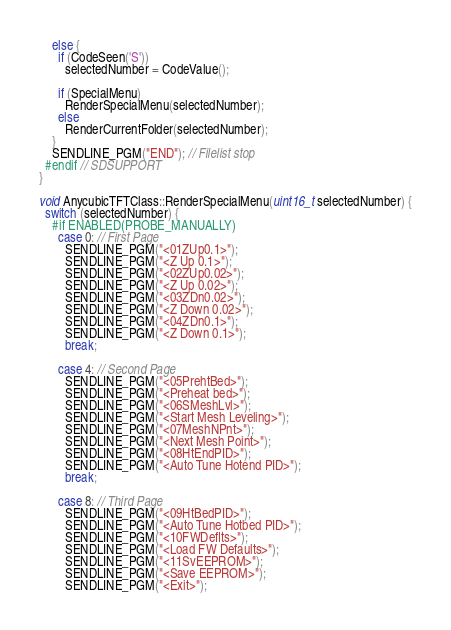Convert code to text. <code><loc_0><loc_0><loc_500><loc_500><_C++_>    else {
      if (CodeSeen('S'))
        selectedNumber = CodeValue();

      if (SpecialMenu)
        RenderSpecialMenu(selectedNumber);
      else
        RenderCurrentFolder(selectedNumber);
    }
    SENDLINE_PGM("END"); // Filelist stop
  #endif // SDSUPPORT
}

void AnycubicTFTClass::RenderSpecialMenu(uint16_t selectedNumber) {
  switch (selectedNumber) {
    #if ENABLED(PROBE_MANUALLY)
      case 0: // First Page
        SENDLINE_PGM("<01ZUp0.1>");
        SENDLINE_PGM("<Z Up 0.1>");
        SENDLINE_PGM("<02ZUp0.02>");
        SENDLINE_PGM("<Z Up 0.02>");
        SENDLINE_PGM("<03ZDn0.02>");
        SENDLINE_PGM("<Z Down 0.02>");
        SENDLINE_PGM("<04ZDn0.1>");
        SENDLINE_PGM("<Z Down 0.1>");
        break;

      case 4: // Second Page
        SENDLINE_PGM("<05PrehtBed>");
        SENDLINE_PGM("<Preheat bed>");
        SENDLINE_PGM("<06SMeshLvl>");
        SENDLINE_PGM("<Start Mesh Leveling>");
        SENDLINE_PGM("<07MeshNPnt>");
        SENDLINE_PGM("<Next Mesh Point>");
        SENDLINE_PGM("<08HtEndPID>");
        SENDLINE_PGM("<Auto Tune Hotend PID>");
        break;

      case 8: // Third Page
        SENDLINE_PGM("<09HtBedPID>");
        SENDLINE_PGM("<Auto Tune Hotbed PID>");
        SENDLINE_PGM("<10FWDeflts>");
        SENDLINE_PGM("<Load FW Defaults>");
        SENDLINE_PGM("<11SvEEPROM>");
        SENDLINE_PGM("<Save EEPROM>");
        SENDLINE_PGM("<Exit>");</code> 